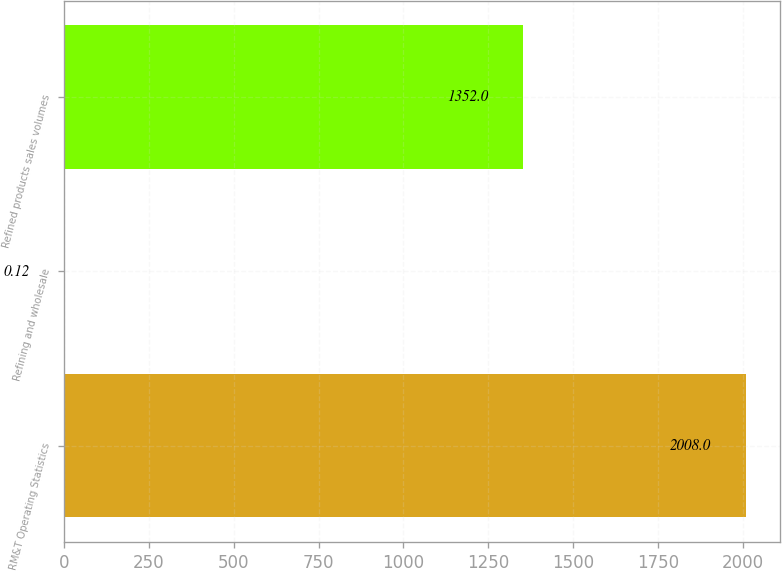Convert chart. <chart><loc_0><loc_0><loc_500><loc_500><bar_chart><fcel>RM&T Operating Statistics<fcel>Refining and wholesale<fcel>Refined products sales volumes<nl><fcel>2008<fcel>0.12<fcel>1352<nl></chart> 